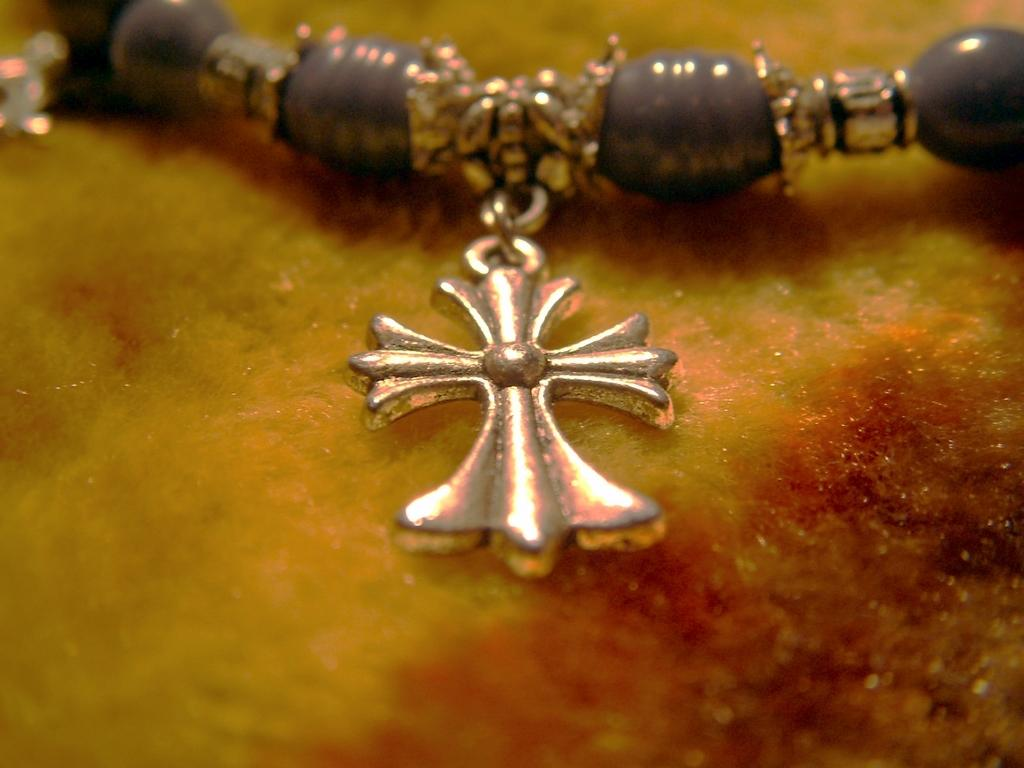What is the main subject in the center of the image? There is a chain in the center of the image. What holiday is being celebrated in the image with the scarecrow? There is no scarecrow present in the image, and therefore no holiday can be associated with it. What word is written on the chain in the image? There is no text or word visible on the chain in the image. 